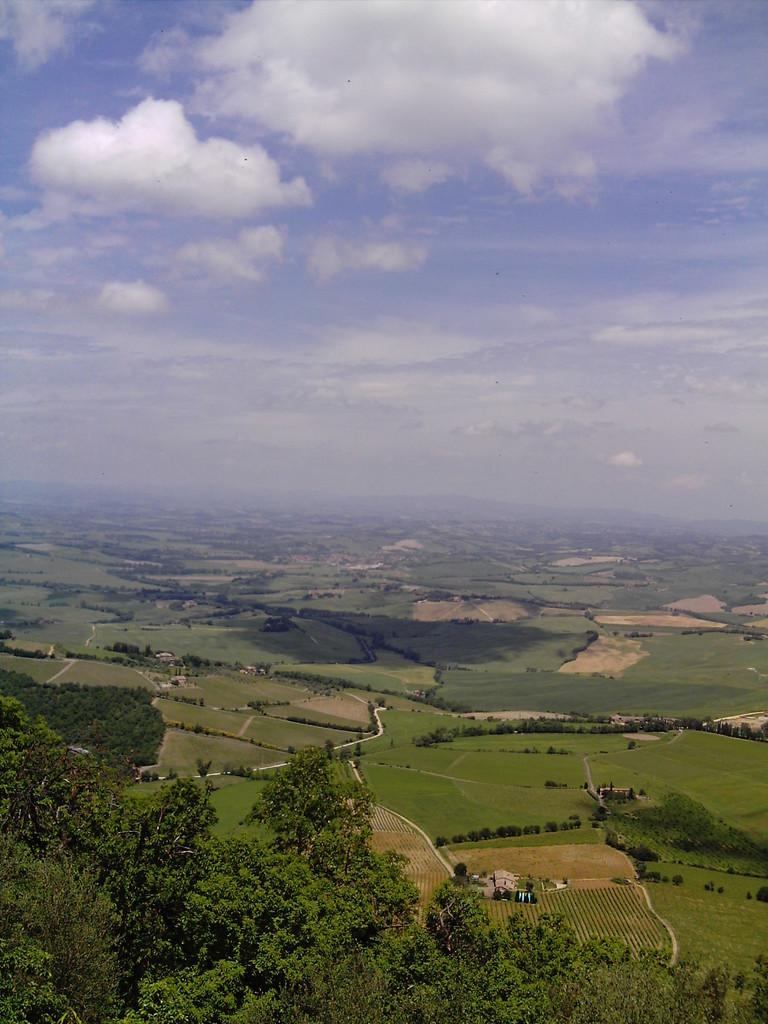What type of terrain is visible in the image? There is ground visible in the image. What type of vegetation can be seen in the image? There are trees in the image. What is visible in the background of the image? The sky is visible in the background of the image. What can be observed in the sky? Clouds are present in the sky. Where is the entrance to the cave located in the image? There is no cave present in the image; it features ground, trees, and sky. 